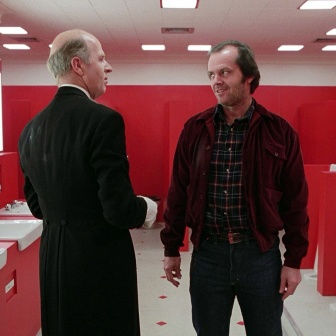What could be the significance of the red color in the bathroom? Red is a color often associated with strong emotions such as passion, anger, or urgency. In the context of this image, the intense red of the bathroom could be used to heighten the atmosphere, suggesting a scene filled with tension or significance. It creates a visually striking setting that draws attention and perhaps adds a layer of psychological intensity to the interaction between the two men. Can you expand on the possible themes that the intense red setting could symbolize? The intense red setting in the bathroom could symbolize a variety of themes. One possibility is the representation of psychological states such as anxiety, tension, or conflict. The red may also serve to highlight the importance or intensity of the conversation between the two men, indicating that what they are discussing holds significant weight or consequence. Additionally, red can represent power and dominance, suggesting that the man in the black suit may hold authority in the conversation. The overall aesthetic could also be a deliberate artistic choice to evoke a sense of surrealism or disorientation, making the viewers question the reality and context of the scene. 